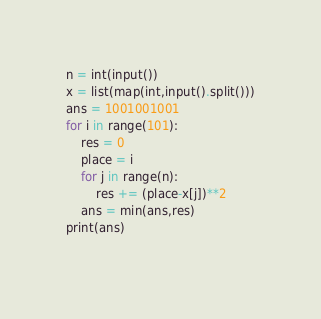Convert code to text. <code><loc_0><loc_0><loc_500><loc_500><_Python_>n = int(input())
x = list(map(int,input().split()))
ans = 1001001001
for i in range(101):
    res = 0
    place = i
    for j in range(n):
        res += (place-x[j])**2
    ans = min(ans,res)
print(ans)
        </code> 